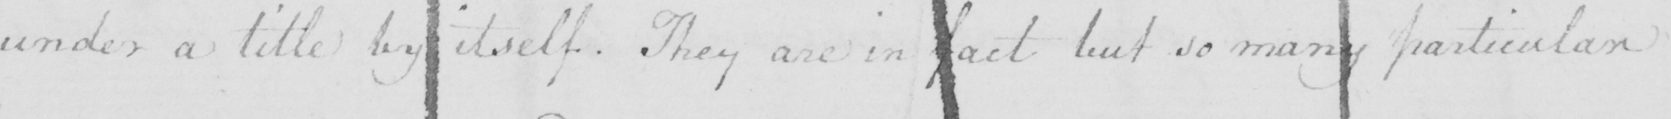What is written in this line of handwriting? under a title by itself . They are in fact but so many particular 